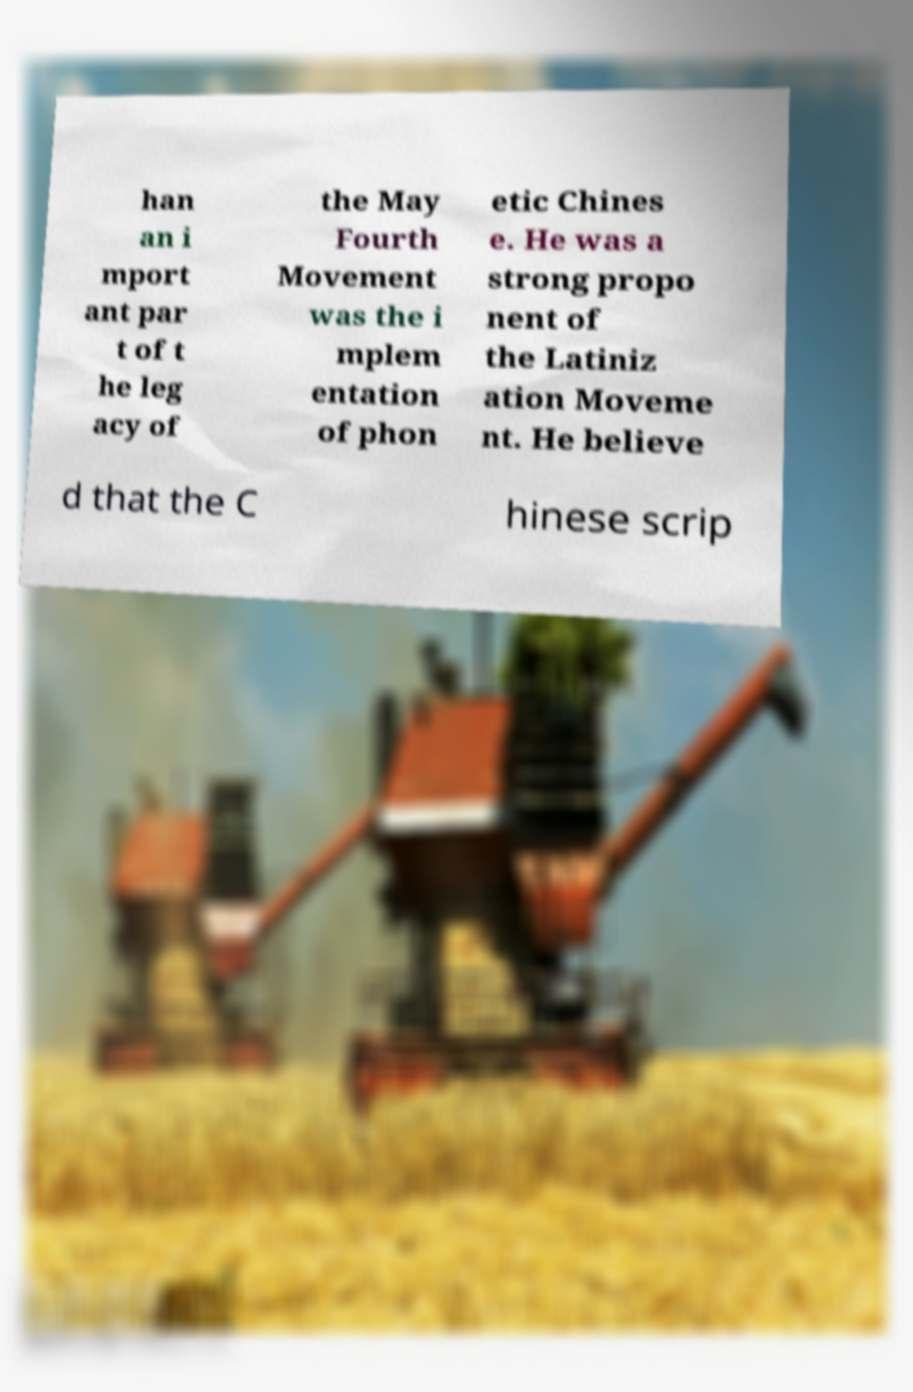Could you assist in decoding the text presented in this image and type it out clearly? han an i mport ant par t of t he leg acy of the May Fourth Movement was the i mplem entation of phon etic Chines e. He was a strong propo nent of the Latiniz ation Moveme nt. He believe d that the C hinese scrip 